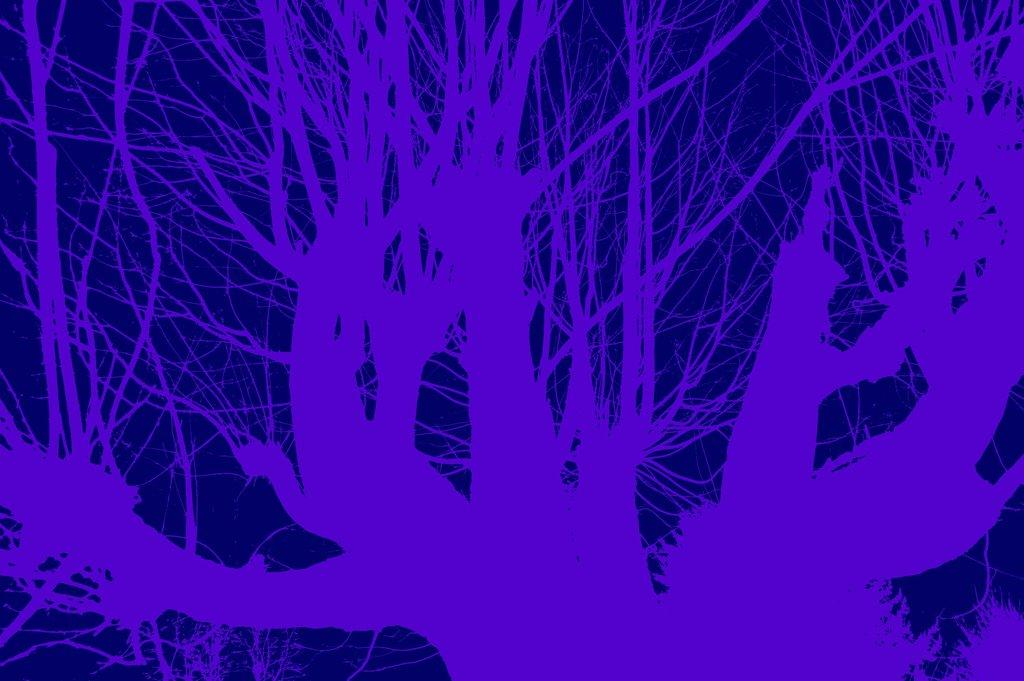What type of plant can be seen in the image? There is a tree in the image. What parts of the tree are visible in the image? The branches of the tree are visible in the image. What type of trade agreement is being discussed by the tree branches in the image? There is no trade agreement or discussion present in the image; it features a tree with visible branches. 